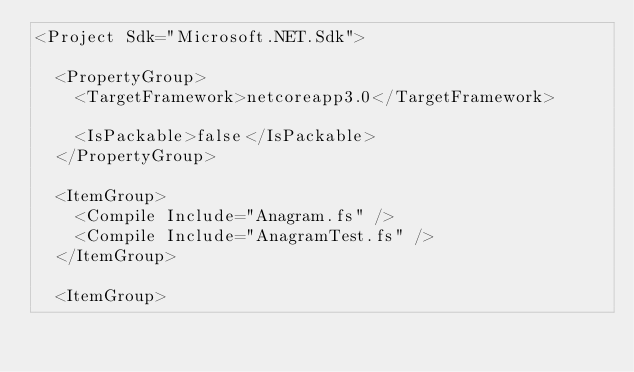Convert code to text. <code><loc_0><loc_0><loc_500><loc_500><_XML_><Project Sdk="Microsoft.NET.Sdk">

  <PropertyGroup>
    <TargetFramework>netcoreapp3.0</TargetFramework>

    <IsPackable>false</IsPackable>
  </PropertyGroup>

  <ItemGroup>
    <Compile Include="Anagram.fs" />
    <Compile Include="AnagramTest.fs" />
  </ItemGroup>

  <ItemGroup></code> 